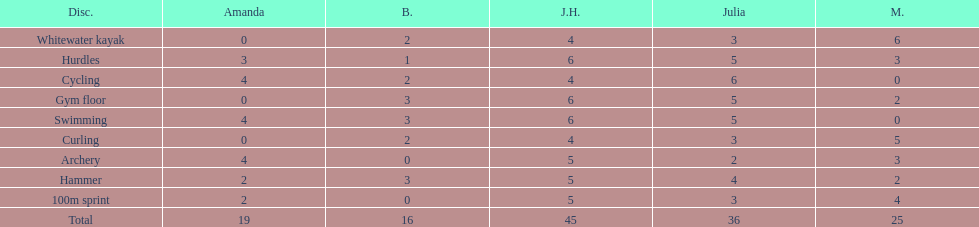Who is the faster runner? Javine H. 